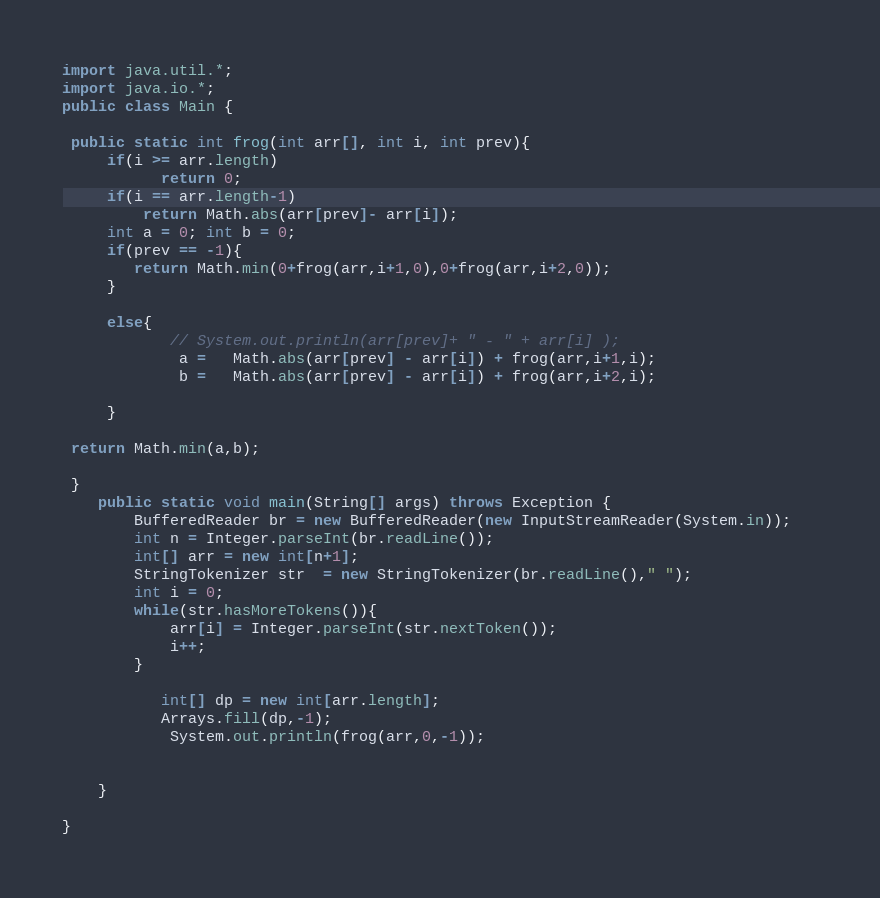<code> <loc_0><loc_0><loc_500><loc_500><_Java_>
import java.util.*;
import java.io.*;
public class Main {
 
 public static int frog(int arr[], int i, int prev){
     if(i >= arr.length)
           return 0;
     if(i == arr.length-1)
         return Math.abs(arr[prev]- arr[i]);
     int a = 0; int b = 0;
     if(prev == -1){
        return Math.min(0+frog(arr,i+1,0),0+frog(arr,i+2,0));
     }
    
     else{
            // System.out.println(arr[prev]+ " - " + arr[i] );
             a =   Math.abs(arr[prev] - arr[i]) + frog(arr,i+1,i);
             b =   Math.abs(arr[prev] - arr[i]) + frog(arr,i+2,i);
     
     }
  
 return Math.min(a,b);
  
 }
    public static void main(String[] args) throws Exception {
        BufferedReader br = new BufferedReader(new InputStreamReader(System.in));   
        int n = Integer.parseInt(br.readLine());
        int[] arr = new int[n+1];
        StringTokenizer str  = new StringTokenizer(br.readLine()," ");
        int i = 0;
        while(str.hasMoreTokens()){
            arr[i] = Integer.parseInt(str.nextToken());
            i++;
        }
        
           int[] dp = new int[arr.length];
           Arrays.fill(dp,-1);
            System.out.println(frog(arr,0,-1));
        
        
    }
    
}
</code> 